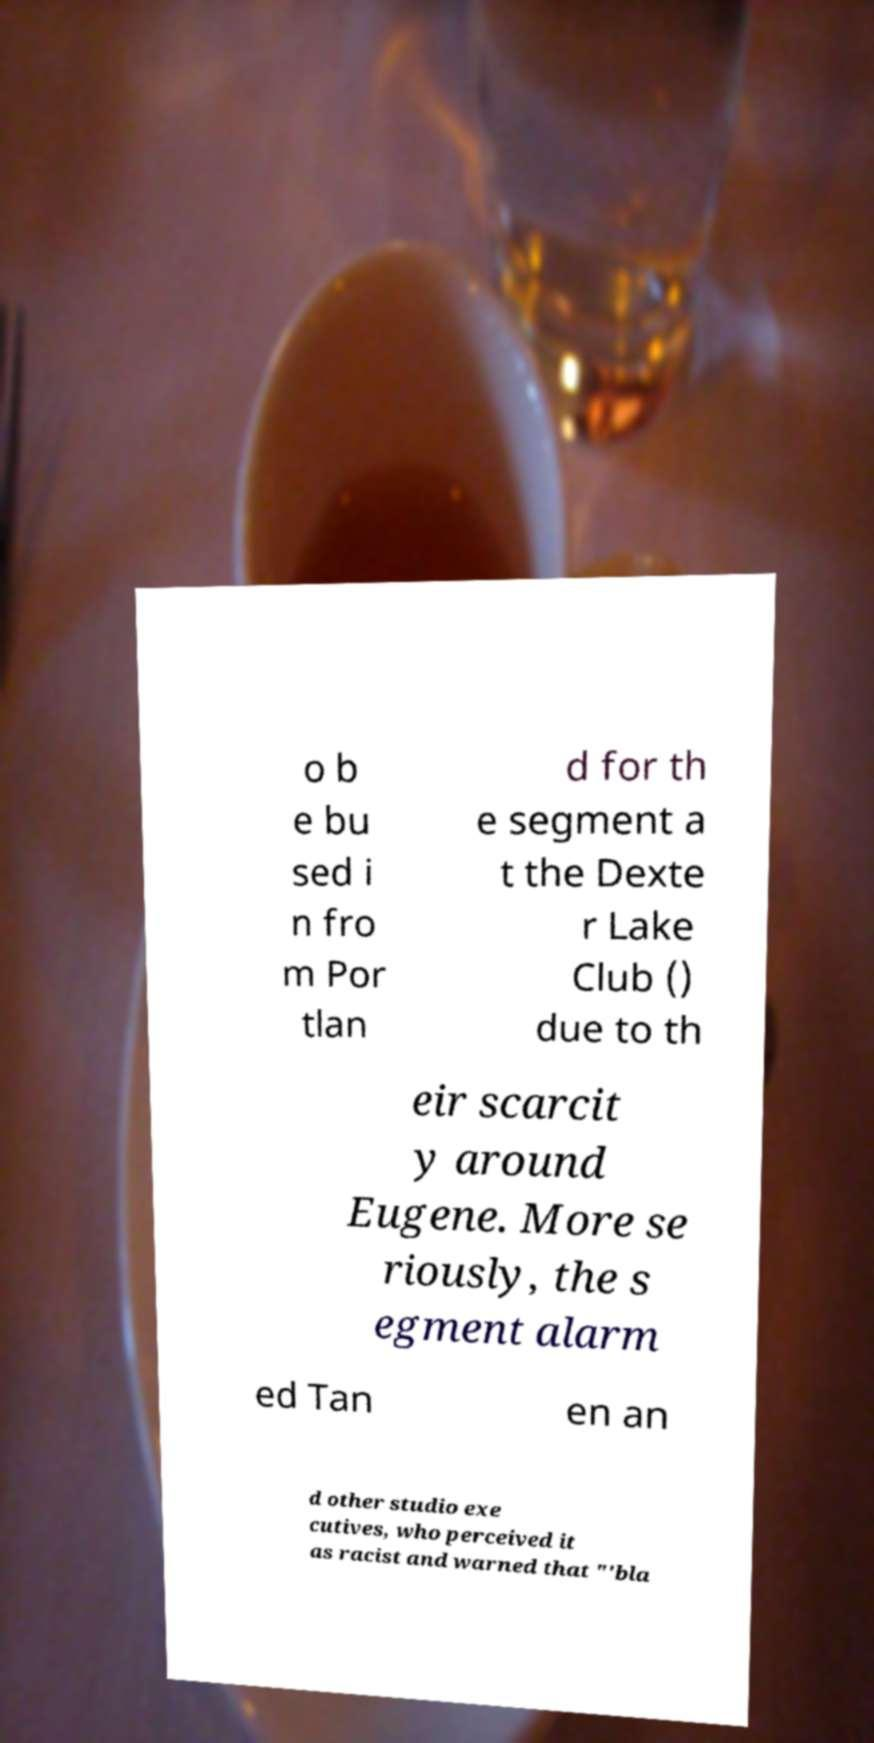Can you accurately transcribe the text from the provided image for me? o b e bu sed i n fro m Por tlan d for th e segment a t the Dexte r Lake Club () due to th eir scarcit y around Eugene. More se riously, the s egment alarm ed Tan en an d other studio exe cutives, who perceived it as racist and warned that "'bla 